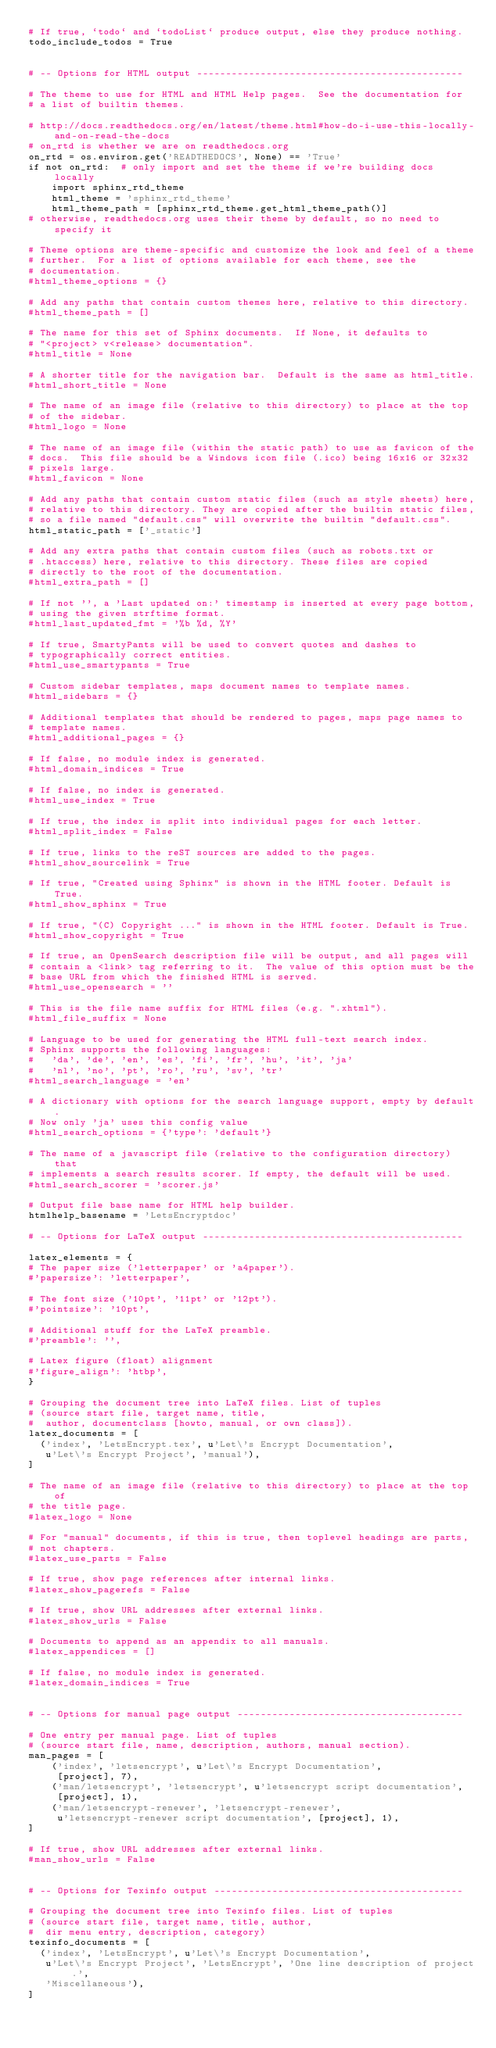Convert code to text. <code><loc_0><loc_0><loc_500><loc_500><_Python_># If true, `todo` and `todoList` produce output, else they produce nothing.
todo_include_todos = True


# -- Options for HTML output ----------------------------------------------

# The theme to use for HTML and HTML Help pages.  See the documentation for
# a list of builtin themes.

# http://docs.readthedocs.org/en/latest/theme.html#how-do-i-use-this-locally-and-on-read-the-docs
# on_rtd is whether we are on readthedocs.org
on_rtd = os.environ.get('READTHEDOCS', None) == 'True'
if not on_rtd:  # only import and set the theme if we're building docs locally
    import sphinx_rtd_theme
    html_theme = 'sphinx_rtd_theme'
    html_theme_path = [sphinx_rtd_theme.get_html_theme_path()]
# otherwise, readthedocs.org uses their theme by default, so no need to specify it

# Theme options are theme-specific and customize the look and feel of a theme
# further.  For a list of options available for each theme, see the
# documentation.
#html_theme_options = {}

# Add any paths that contain custom themes here, relative to this directory.
#html_theme_path = []

# The name for this set of Sphinx documents.  If None, it defaults to
# "<project> v<release> documentation".
#html_title = None

# A shorter title for the navigation bar.  Default is the same as html_title.
#html_short_title = None

# The name of an image file (relative to this directory) to place at the top
# of the sidebar.
#html_logo = None

# The name of an image file (within the static path) to use as favicon of the
# docs.  This file should be a Windows icon file (.ico) being 16x16 or 32x32
# pixels large.
#html_favicon = None

# Add any paths that contain custom static files (such as style sheets) here,
# relative to this directory. They are copied after the builtin static files,
# so a file named "default.css" will overwrite the builtin "default.css".
html_static_path = ['_static']

# Add any extra paths that contain custom files (such as robots.txt or
# .htaccess) here, relative to this directory. These files are copied
# directly to the root of the documentation.
#html_extra_path = []

# If not '', a 'Last updated on:' timestamp is inserted at every page bottom,
# using the given strftime format.
#html_last_updated_fmt = '%b %d, %Y'

# If true, SmartyPants will be used to convert quotes and dashes to
# typographically correct entities.
#html_use_smartypants = True

# Custom sidebar templates, maps document names to template names.
#html_sidebars = {}

# Additional templates that should be rendered to pages, maps page names to
# template names.
#html_additional_pages = {}

# If false, no module index is generated.
#html_domain_indices = True

# If false, no index is generated.
#html_use_index = True

# If true, the index is split into individual pages for each letter.
#html_split_index = False

# If true, links to the reST sources are added to the pages.
#html_show_sourcelink = True

# If true, "Created using Sphinx" is shown in the HTML footer. Default is True.
#html_show_sphinx = True

# If true, "(C) Copyright ..." is shown in the HTML footer. Default is True.
#html_show_copyright = True

# If true, an OpenSearch description file will be output, and all pages will
# contain a <link> tag referring to it.  The value of this option must be the
# base URL from which the finished HTML is served.
#html_use_opensearch = ''

# This is the file name suffix for HTML files (e.g. ".xhtml").
#html_file_suffix = None

# Language to be used for generating the HTML full-text search index.
# Sphinx supports the following languages:
#   'da', 'de', 'en', 'es', 'fi', 'fr', 'hu', 'it', 'ja'
#   'nl', 'no', 'pt', 'ro', 'ru', 'sv', 'tr'
#html_search_language = 'en'

# A dictionary with options for the search language support, empty by default.
# Now only 'ja' uses this config value
#html_search_options = {'type': 'default'}

# The name of a javascript file (relative to the configuration directory) that
# implements a search results scorer. If empty, the default will be used.
#html_search_scorer = 'scorer.js'

# Output file base name for HTML help builder.
htmlhelp_basename = 'LetsEncryptdoc'

# -- Options for LaTeX output ---------------------------------------------

latex_elements = {
# The paper size ('letterpaper' or 'a4paper').
#'papersize': 'letterpaper',

# The font size ('10pt', '11pt' or '12pt').
#'pointsize': '10pt',

# Additional stuff for the LaTeX preamble.
#'preamble': '',

# Latex figure (float) alignment
#'figure_align': 'htbp',
}

# Grouping the document tree into LaTeX files. List of tuples
# (source start file, target name, title,
#  author, documentclass [howto, manual, or own class]).
latex_documents = [
  ('index', 'LetsEncrypt.tex', u'Let\'s Encrypt Documentation',
   u'Let\'s Encrypt Project', 'manual'),
]

# The name of an image file (relative to this directory) to place at the top of
# the title page.
#latex_logo = None

# For "manual" documents, if this is true, then toplevel headings are parts,
# not chapters.
#latex_use_parts = False

# If true, show page references after internal links.
#latex_show_pagerefs = False

# If true, show URL addresses after external links.
#latex_show_urls = False

# Documents to append as an appendix to all manuals.
#latex_appendices = []

# If false, no module index is generated.
#latex_domain_indices = True


# -- Options for manual page output ---------------------------------------

# One entry per manual page. List of tuples
# (source start file, name, description, authors, manual section).
man_pages = [
    ('index', 'letsencrypt', u'Let\'s Encrypt Documentation',
     [project], 7),
    ('man/letsencrypt', 'letsencrypt', u'letsencrypt script documentation',
     [project], 1),
    ('man/letsencrypt-renewer', 'letsencrypt-renewer',
     u'letsencrypt-renewer script documentation', [project], 1),
]

# If true, show URL addresses after external links.
#man_show_urls = False


# -- Options for Texinfo output -------------------------------------------

# Grouping the document tree into Texinfo files. List of tuples
# (source start file, target name, title, author,
#  dir menu entry, description, category)
texinfo_documents = [
  ('index', 'LetsEncrypt', u'Let\'s Encrypt Documentation',
   u'Let\'s Encrypt Project', 'LetsEncrypt', 'One line description of project.',
   'Miscellaneous'),
]
</code> 